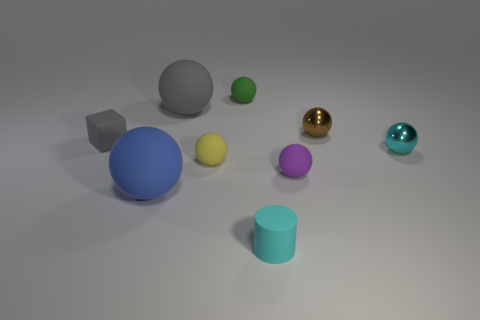There is a small yellow thing to the right of the blue matte sphere; does it have the same shape as the metallic object that is left of the cyan shiny thing?
Provide a short and direct response. Yes. There is a object that is the same color as the cylinder; what is its size?
Provide a short and direct response. Small. Does the matte cube have the same color as the large sphere that is to the right of the big blue ball?
Ensure brevity in your answer.  Yes. What is the material of the gray object that is right of the big matte thing in front of the tiny gray cube?
Offer a very short reply. Rubber. What number of things are objects left of the gray rubber sphere or tiny green matte things?
Provide a succinct answer. 3. Is the number of matte objects that are in front of the tiny cyan metallic thing the same as the number of big blue rubber spheres that are behind the big gray rubber object?
Provide a short and direct response. No. What material is the tiny object behind the gray matte object that is behind the tiny matte thing left of the large gray thing?
Provide a succinct answer. Rubber. What is the size of the matte thing that is in front of the purple rubber thing and left of the cyan cylinder?
Offer a terse response. Large. Is the shape of the tiny purple rubber thing the same as the tiny brown object?
Give a very brief answer. Yes. What shape is the cyan object that is the same material as the green thing?
Provide a short and direct response. Cylinder. 